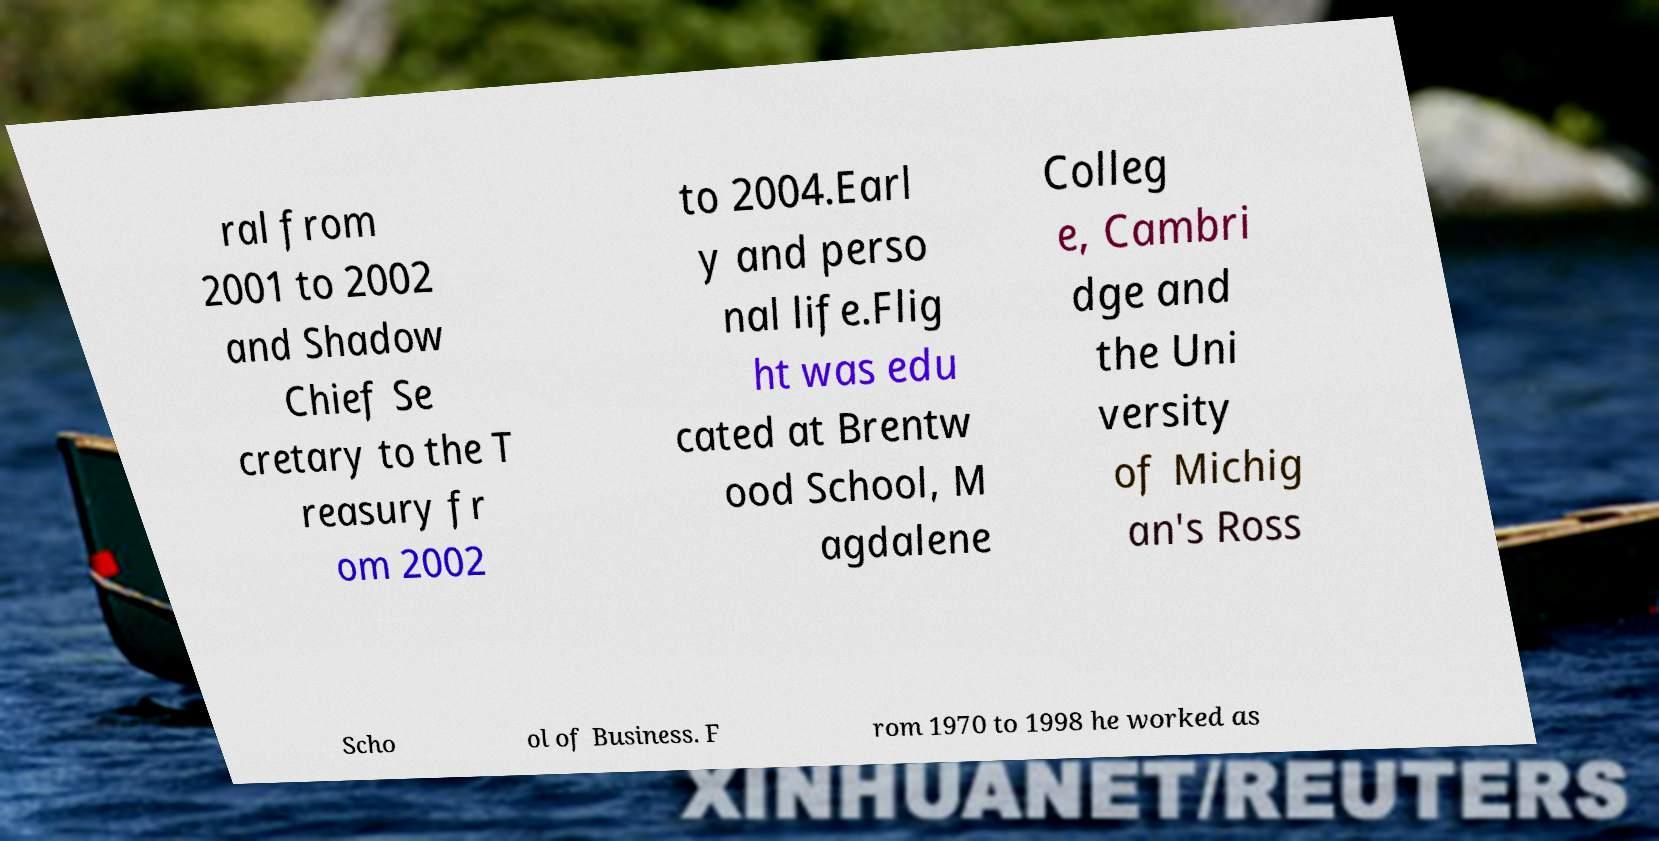Could you extract and type out the text from this image? ral from 2001 to 2002 and Shadow Chief Se cretary to the T reasury fr om 2002 to 2004.Earl y and perso nal life.Flig ht was edu cated at Brentw ood School, M agdalene Colleg e, Cambri dge and the Uni versity of Michig an's Ross Scho ol of Business. F rom 1970 to 1998 he worked as 